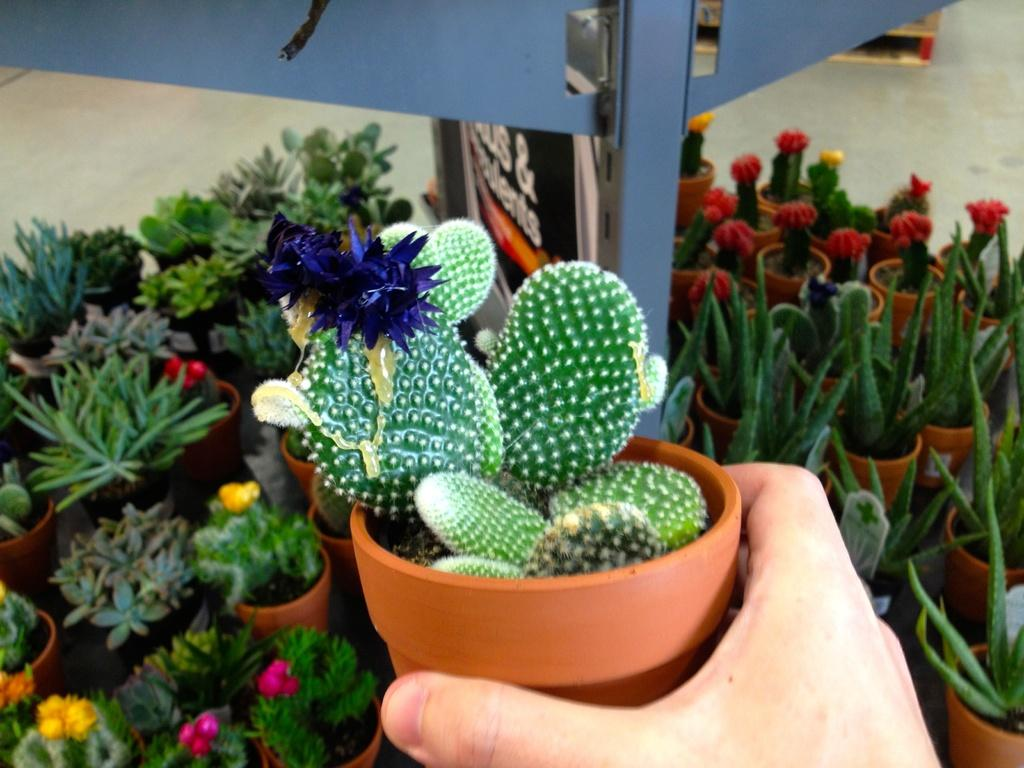What is the person holding in the image? There is a plant pot in a person's hand. Are there any other plant pots visible in the image? Yes, there are plant pots in the background of the image. What else can be seen on the ground in the background of the image? There are other objects on the ground in the background of the image. How does the person's digestion process affect the plant pot in their hand? The person's digestion process does not affect the plant pot in their hand, as it is an external object being held. 